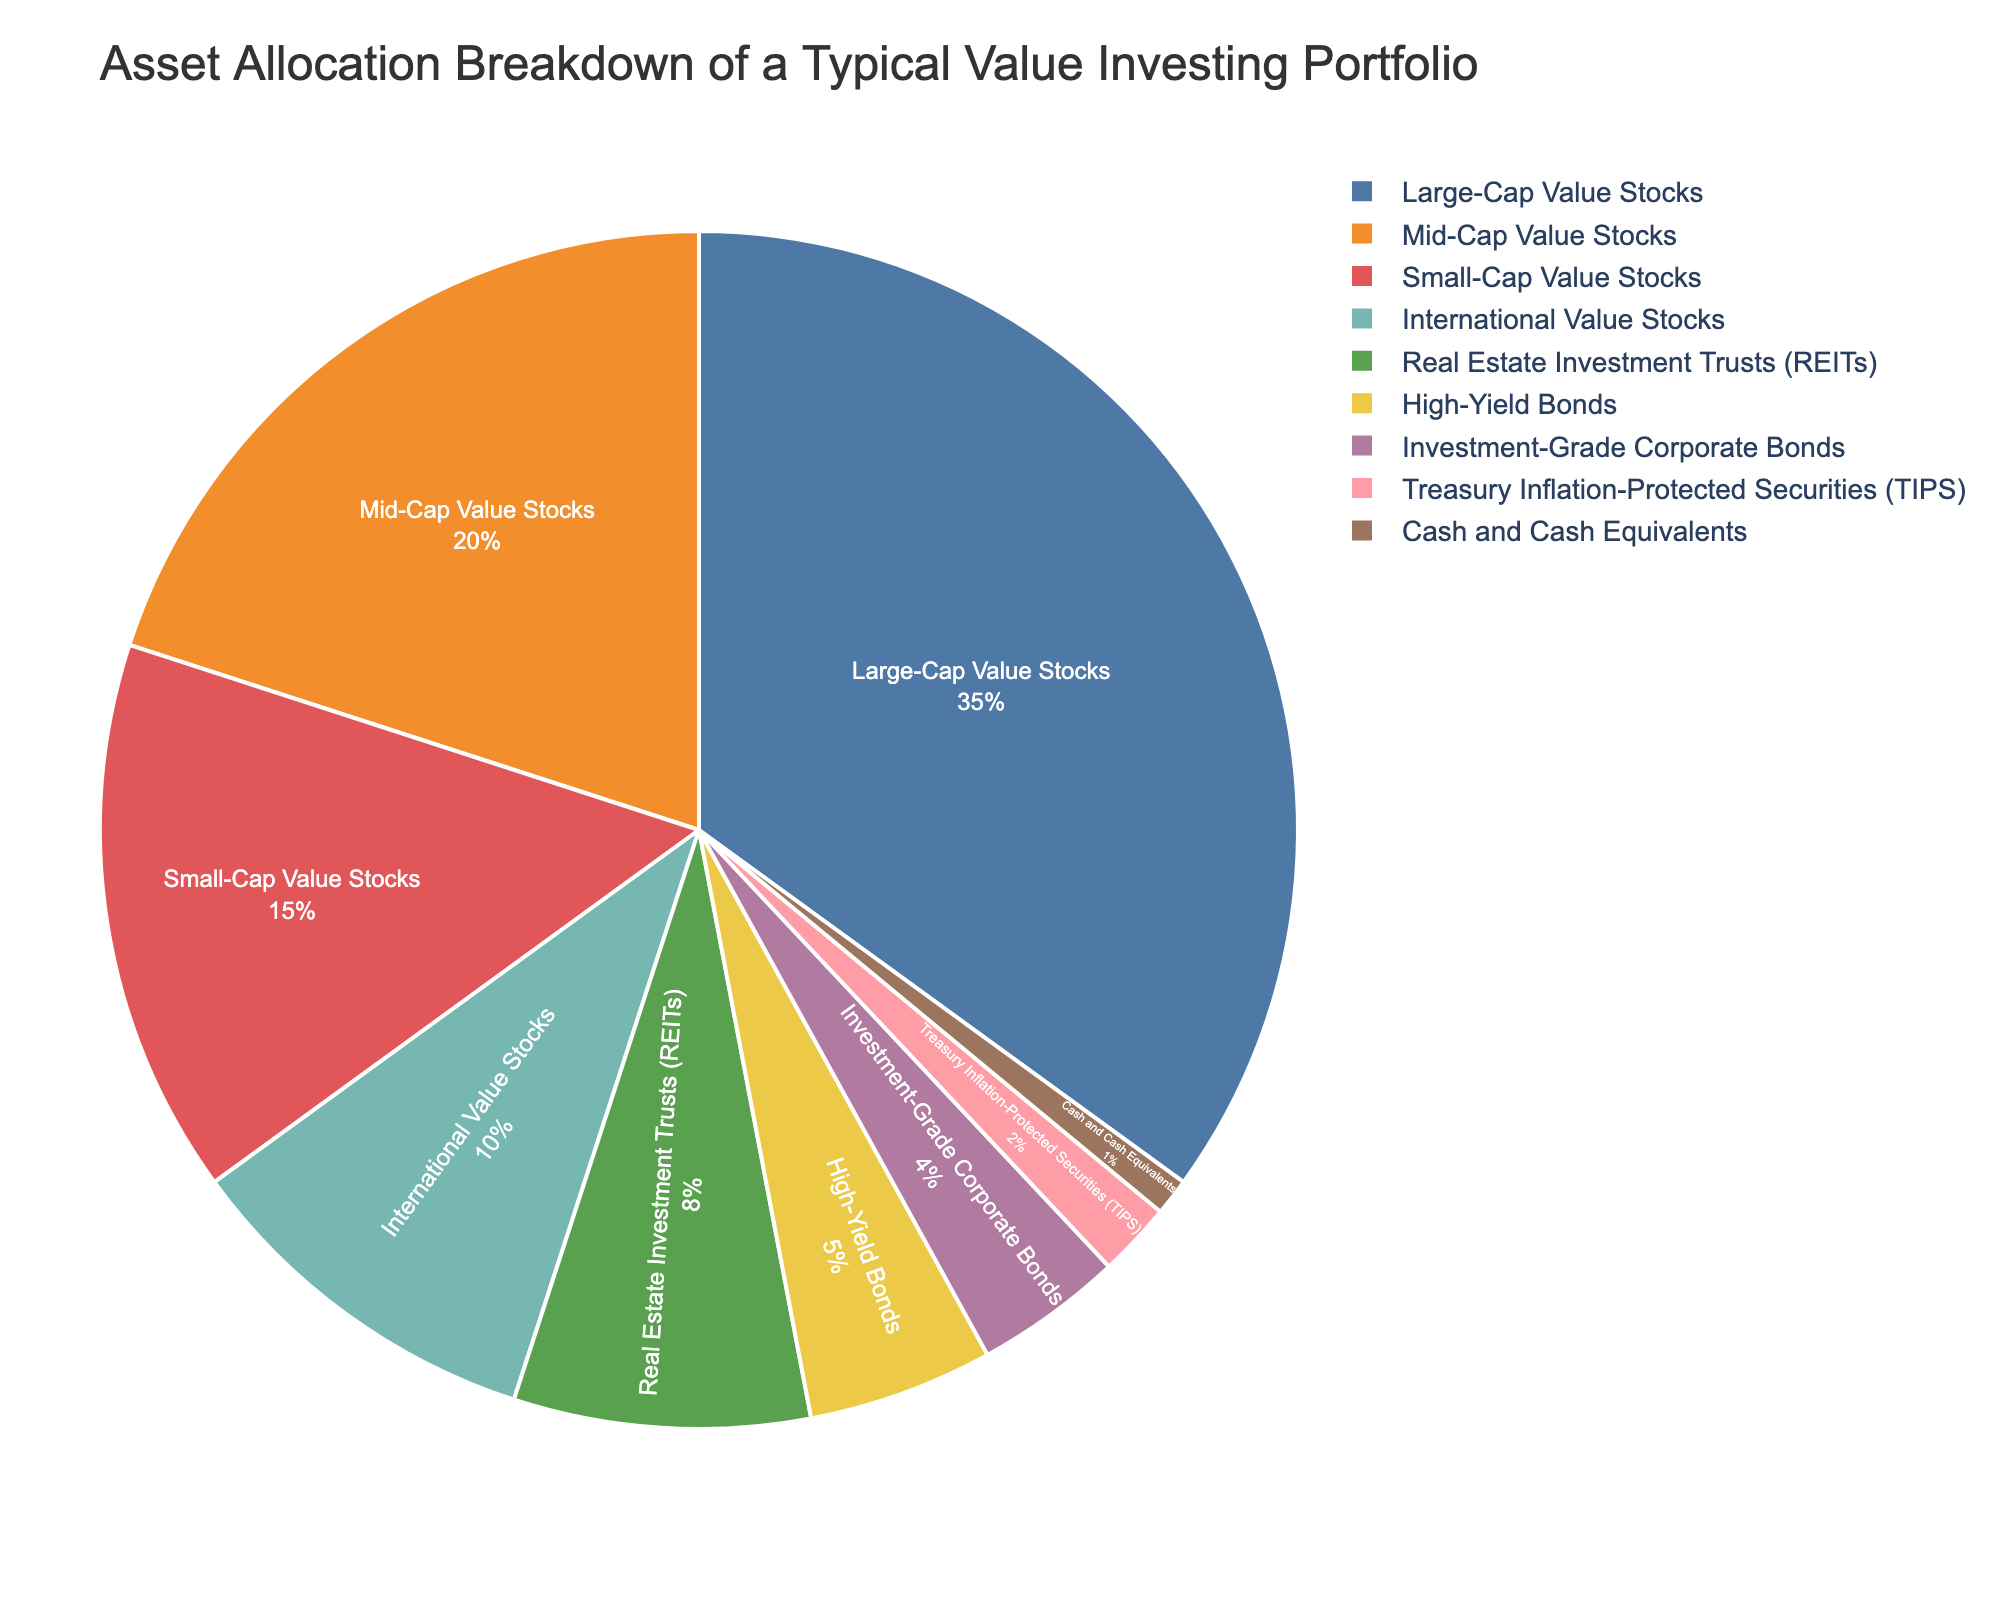What percentage of the portfolio is allocated to Large-Cap Value Stocks? Look at the pie chart segment labeled "Large-Cap Value Stocks" to find the percentage associated with this asset class, which is shown as 35%.
Answer: 35% What is the total percentage allocated to value stocks across all market caps? Sum the percentages of Large-Cap Value Stocks (35%), Mid-Cap Value Stocks (20%), and Small-Cap Value Stocks (15%). The total is 35% + 20% + 15% = 70%.
Answer: 70% Which asset class has the smallest allocation in the portfolio? Look at the smallest segment in the pie chart, which is labeled "Cash and Cash Equivalents" and has a 1% allocation.
Answer: Cash and Cash Equivalents Is the allocation to Real Estate Investment Trusts (REITs) greater than that to High-Yield Bonds? Compare the percentages of REITs (8%) and High-Yield Bonds (5%). Since 8% is greater than 5%, REITs have a greater allocation.
Answer: Yes What is the difference in percentage between Mid-Cap Value Stocks and International Value Stocks? Subtract the percentage of International Value Stocks (10%) from that of Mid-Cap Value Stocks (20%): 20% - 10% = 10%.
Answer: 10% If the allocations to International Value Stocks and High-Yield Bonds were combined, what would their total percentage be? Add the percentages of International Value Stocks (10%) and High-Yield Bonds (5%): 10% + 5% = 15%.
Answer: 15% Which asset class is allocated the most in the portfolio and what percentage does it represent? Identify the largest segment in the pie chart, which is labeled "Large-Cap Value Stocks" with a 35% allocation.
Answer: Large-Cap Value Stocks, 35% There are three types of bond investments in the portfolio: High-Yield Bonds, Investment-Grade Corporate Bonds, and Treasury Inflation-Protected Securities (TIPS). What is their combined percentage allocation? Sum the percentages of High-Yield Bonds (5%), Investment-Grade Corporate Bonds (4%), and TIPS (2%). The total is 5% + 4% + 2% = 11%.
Answer: 11% How does the allocation to Mid-Cap Value Stocks compare to that of Small-Cap Value Stocks? Compare the percentages for these two asset classes: Mid-Cap Value Stocks are allocated 20%, while Small-Cap Value Stocks are allocated 15%. Since 20% is greater than 15%, Mid-Cap Value Stocks have a higher allocation.
Answer: Mid-Cap Value Stocks have a higher allocation If you were to exclude the allocation to Cash and Cash Equivalents, what would be the total percentage of the remaining portfolio? Subtract the percentage of Cash and Cash Equivalents (1%) from the total portfolio (100%): 100% - 1% = 99%.
Answer: 99% 